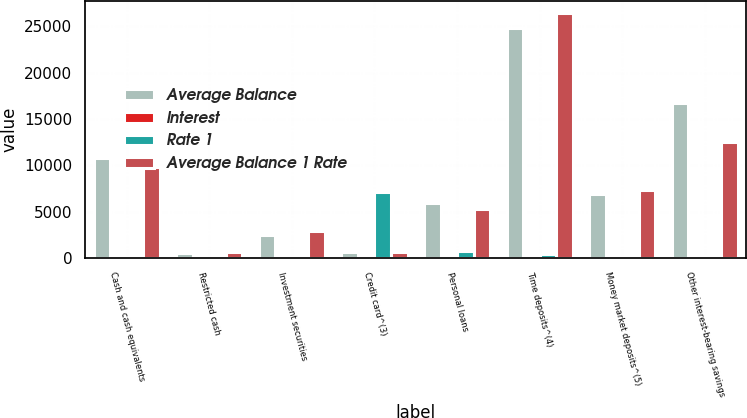Convert chart to OTSL. <chart><loc_0><loc_0><loc_500><loc_500><stacked_bar_chart><ecel><fcel>Cash and cash equivalents<fcel>Restricted cash<fcel>Investment securities<fcel>Credit card^(3)<fcel>Personal loans<fcel>Time deposits^(4)<fcel>Money market deposits^(5)<fcel>Other interest-bearing savings<nl><fcel>Average Balance<fcel>10806<fcel>540<fcel>2445<fcel>585.5<fcel>5895<fcel>24833<fcel>6939<fcel>16725<nl><fcel>Interest<fcel>0.52<fcel>0.37<fcel>1.55<fcel>12.5<fcel>12.19<fcel>1.77<fcel>1.08<fcel>1.04<nl><fcel>Rate 1<fcel>56<fcel>2<fcel>38<fcel>7155<fcel>719<fcel>439<fcel>75<fcel>173<nl><fcel>Average Balance 1 Rate<fcel>9840<fcel>631<fcel>2876<fcel>585.5<fcel>5245<fcel>26415<fcel>7280<fcel>12538<nl></chart> 